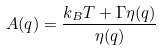<formula> <loc_0><loc_0><loc_500><loc_500>A ( q ) = \frac { k _ { B } T + \Gamma \eta ( q ) } { \eta ( q ) } \\</formula> 